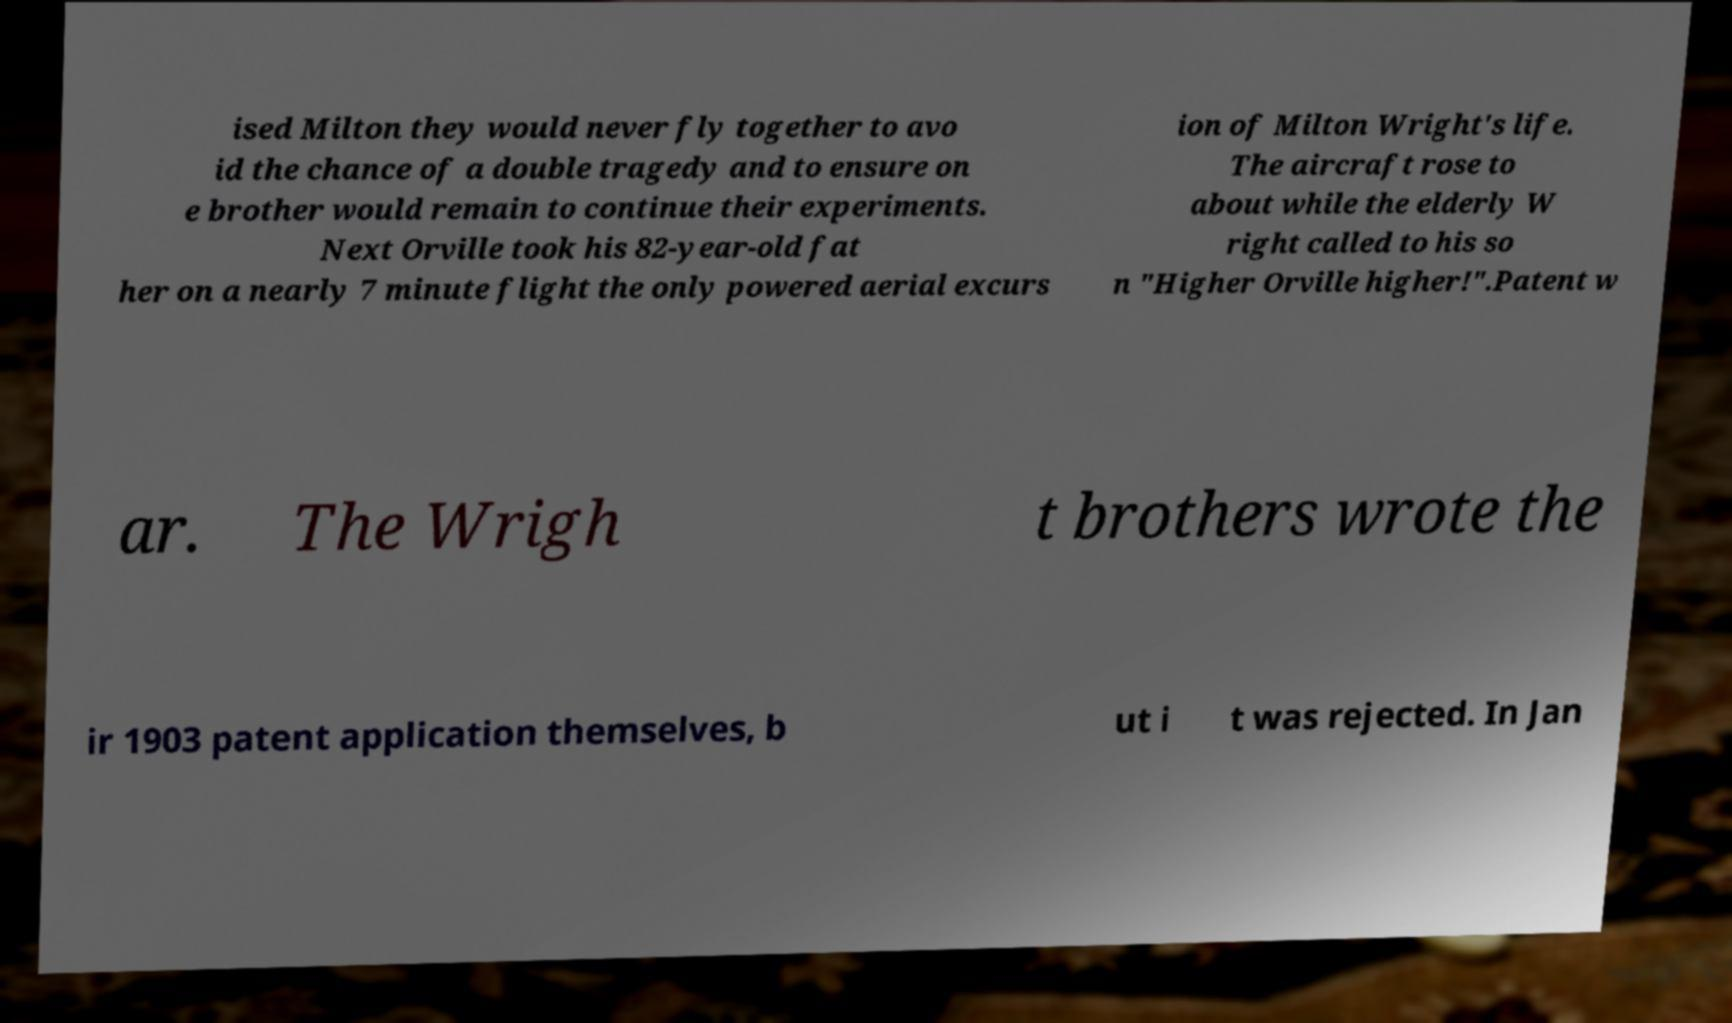I need the written content from this picture converted into text. Can you do that? ised Milton they would never fly together to avo id the chance of a double tragedy and to ensure on e brother would remain to continue their experiments. Next Orville took his 82-year-old fat her on a nearly 7 minute flight the only powered aerial excurs ion of Milton Wright's life. The aircraft rose to about while the elderly W right called to his so n "Higher Orville higher!".Patent w ar. The Wrigh t brothers wrote the ir 1903 patent application themselves, b ut i t was rejected. In Jan 